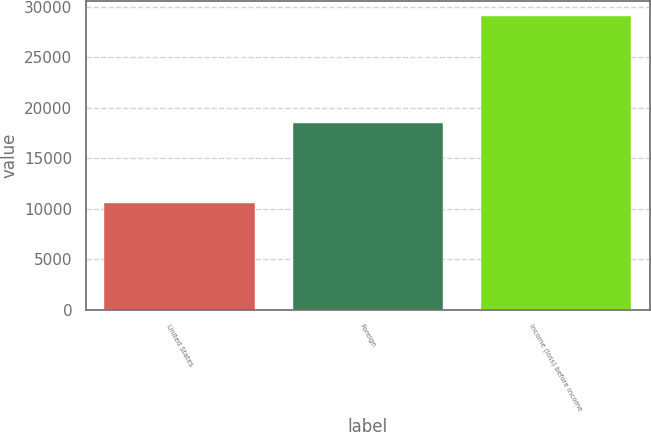Convert chart. <chart><loc_0><loc_0><loc_500><loc_500><bar_chart><fcel>United States<fcel>Foreign<fcel>Income (loss) before income<nl><fcel>10599<fcel>18494<fcel>29093<nl></chart> 